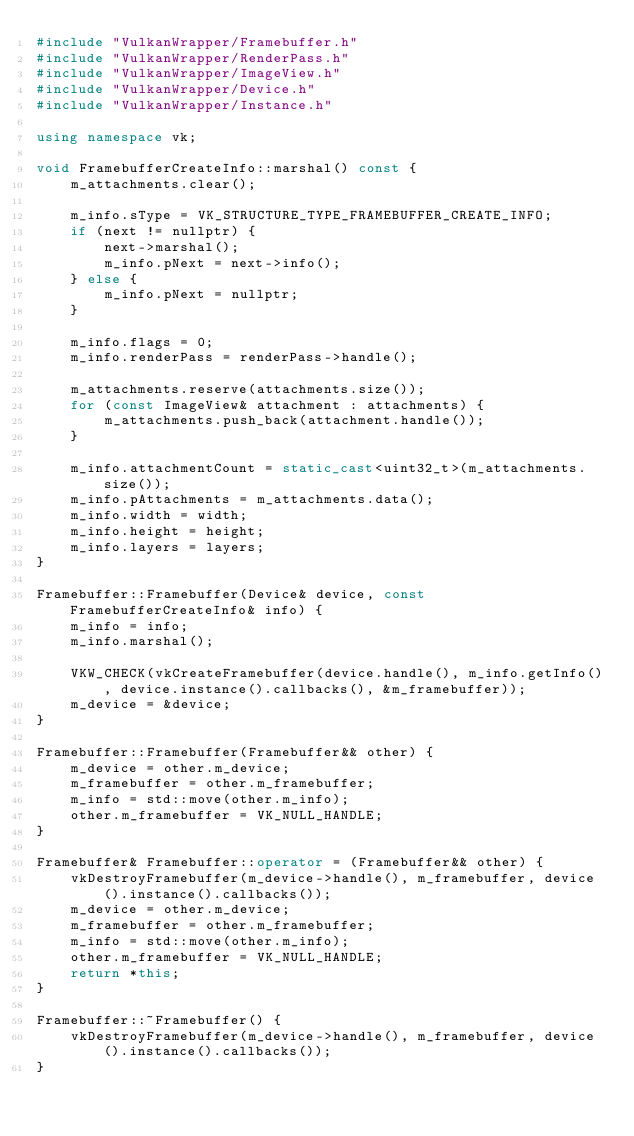<code> <loc_0><loc_0><loc_500><loc_500><_C++_>#include "VulkanWrapper/Framebuffer.h"
#include "VulkanWrapper/RenderPass.h"
#include "VulkanWrapper/ImageView.h"
#include "VulkanWrapper/Device.h"
#include "VulkanWrapper/Instance.h"

using namespace vk;

void FramebufferCreateInfo::marshal() const {
    m_attachments.clear();

    m_info.sType = VK_STRUCTURE_TYPE_FRAMEBUFFER_CREATE_INFO;
    if (next != nullptr) {
        next->marshal();
        m_info.pNext = next->info();
    } else {
        m_info.pNext = nullptr;
    }

    m_info.flags = 0;
    m_info.renderPass = renderPass->handle();

    m_attachments.reserve(attachments.size());
    for (const ImageView& attachment : attachments) {
        m_attachments.push_back(attachment.handle());
    }

    m_info.attachmentCount = static_cast<uint32_t>(m_attachments.size());
    m_info.pAttachments = m_attachments.data();
    m_info.width = width;
    m_info.height = height;
    m_info.layers = layers;
}

Framebuffer::Framebuffer(Device& device, const FramebufferCreateInfo& info) {
    m_info = info;
    m_info.marshal();

    VKW_CHECK(vkCreateFramebuffer(device.handle(), m_info.getInfo(), device.instance().callbacks(), &m_framebuffer));
    m_device = &device;
}

Framebuffer::Framebuffer(Framebuffer&& other) {
    m_device = other.m_device;
    m_framebuffer = other.m_framebuffer;
    m_info = std::move(other.m_info);
    other.m_framebuffer = VK_NULL_HANDLE;
}

Framebuffer& Framebuffer::operator = (Framebuffer&& other) {
    vkDestroyFramebuffer(m_device->handle(), m_framebuffer, device().instance().callbacks());
    m_device = other.m_device;
    m_framebuffer = other.m_framebuffer;
    m_info = std::move(other.m_info);
    other.m_framebuffer = VK_NULL_HANDLE;
    return *this;
}

Framebuffer::~Framebuffer() {
    vkDestroyFramebuffer(m_device->handle(), m_framebuffer, device().instance().callbacks());
}</code> 